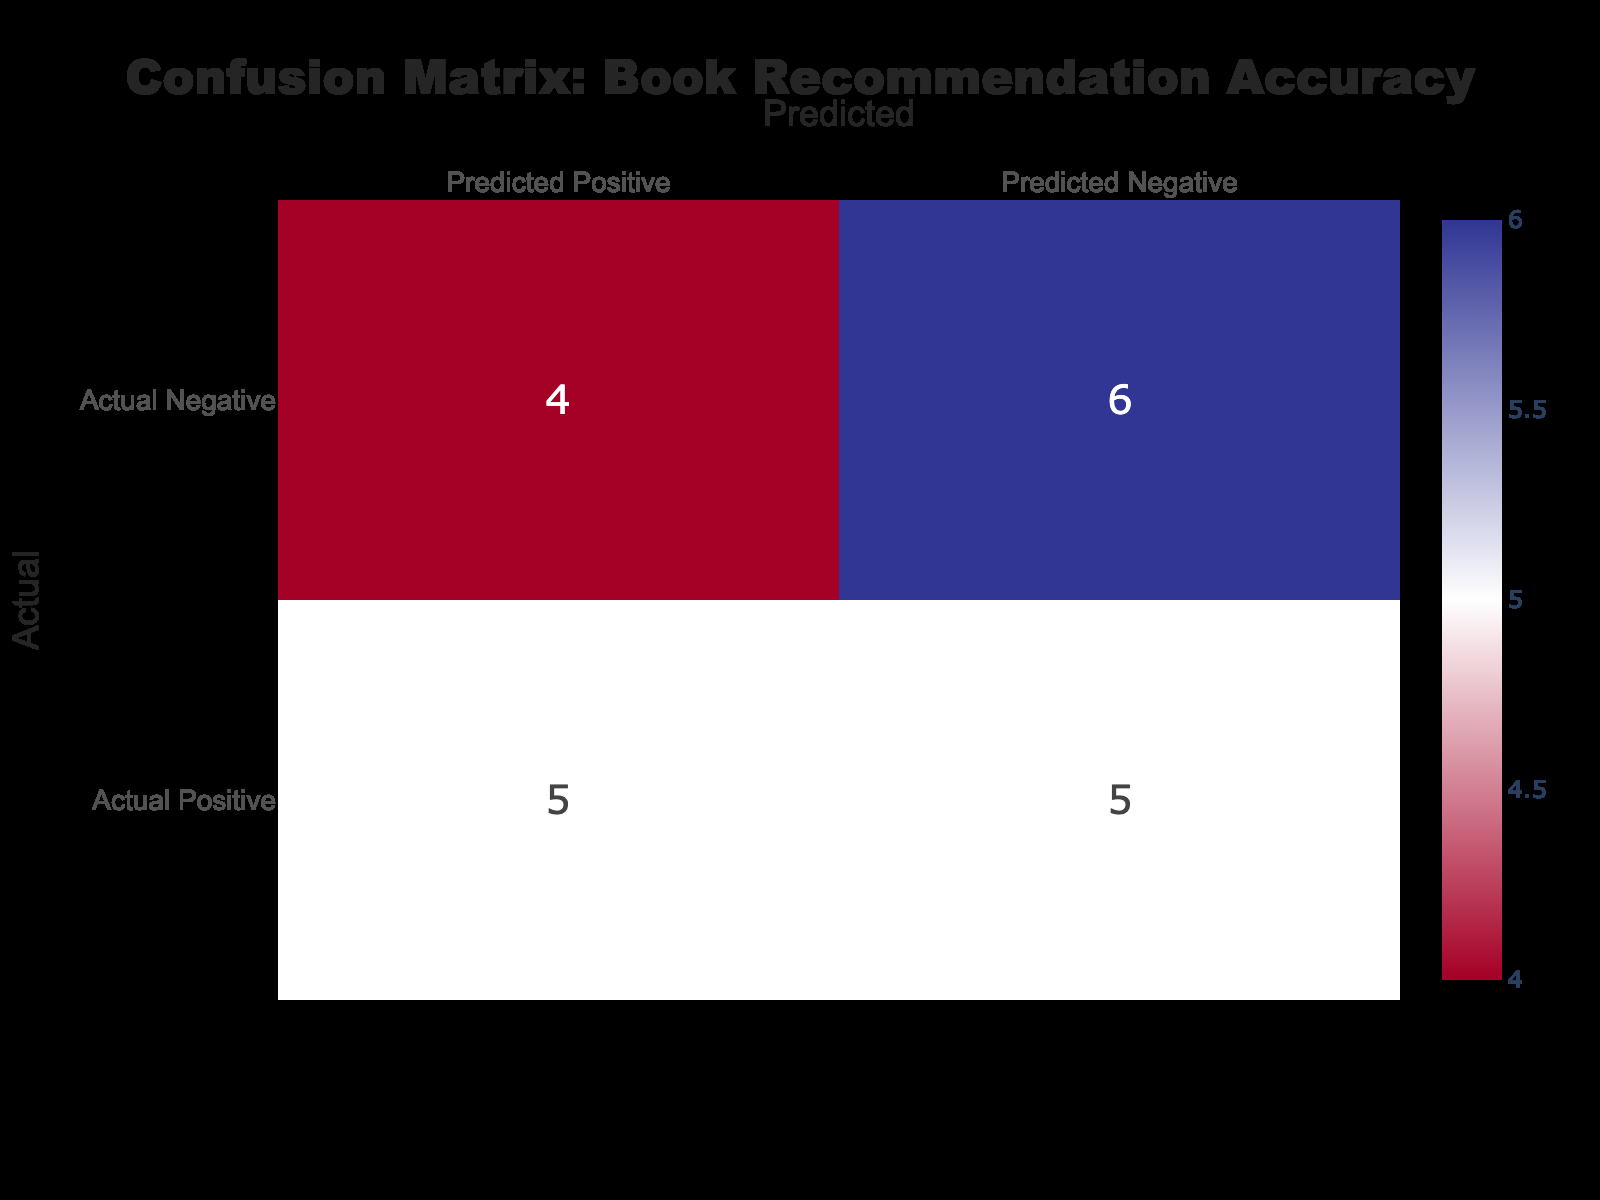What is the total number of true positives (TP) in the dataset? To find the total true positives (TP), we sum the TP values from each row in the table: 1 (Young Adult, The Hunger Games) + 1 (Adult, Becoming) + 1 (Senior, The Night Circus) + 1 (Young Adult, 1984) + 1 (Senior, The Alchemist) = 5.
Answer: 5 How many false positives (FP) are there for the Adult demographic? The FP for the Adult demographic is visible in the rows where the User Demographic is "Adult." There are two instances: one from "The Fault in Our Stars" (1 FP) and one from "Educated" (1 FP), totaling 2 FP.
Answer: 2 What is the sum of true negatives (TN) and false negatives (FN) across all demographics? To find the sum of TN and FN, we first calculate TN as 1 (from Adult, Becoming) + 1 (from Senior, The Alchemist) = 2 TN and FN as 0 (from The Hunger Games) + 1 (from Harry Potter) + 0 + 1 (from The Fault in Our Stars) + 1 (from To Kill a Mockingbird) = 3 FN. Thus, the total is 2 + 3 = 5.
Answer: 5 Is there a book that was correctly recommended to every demographic? By examining the table, the only books that achieved true positives across any demographic were "Becoming," "The Night Circus," and "1984," each being recommended to corresponding demographics. However, none were successful across all demographics, thus the answer is No.
Answer: No How many books were given as recommendations in total? To calculate the total number of recommendations, count the number of rows in the table: There are 10 rows, thus there were 10 total book recommendations made across the different demographics.
Answer: 10 Which User Demographic has the highest number of false negatives (FN)? The highest FN is found by counting FN for each demographic: "Young Adult" has 2 (Harry Potter, To Kill a Mockingbird), "Adult" has 1 (The Fault in Our Stars), and "Senior" has 1 (The Hobbit). The Young Adult has the highest FN at 2.
Answer: Young Adult What is the total accuracy of the recommendation system based on the data? To compute the accuracy, use the formula (TP + TN) / (TP + FP + TN + FN). Here, TP = 5, TN = 2, FP = 3, FN = 3. Therefore, accuracy = (5 + 2) / (5 + 3 + 2 + 3) = 7/13, which is approximately 0.538 or 53.8%.
Answer: 53.8% Are there any instances of false negatives (FN) for the Senior demographic? By reviewing the rows associated with the Senior demographic, only one instance has a FN: The Hobbit (1 FN). Thus, the answer is Yes.
Answer: Yes 